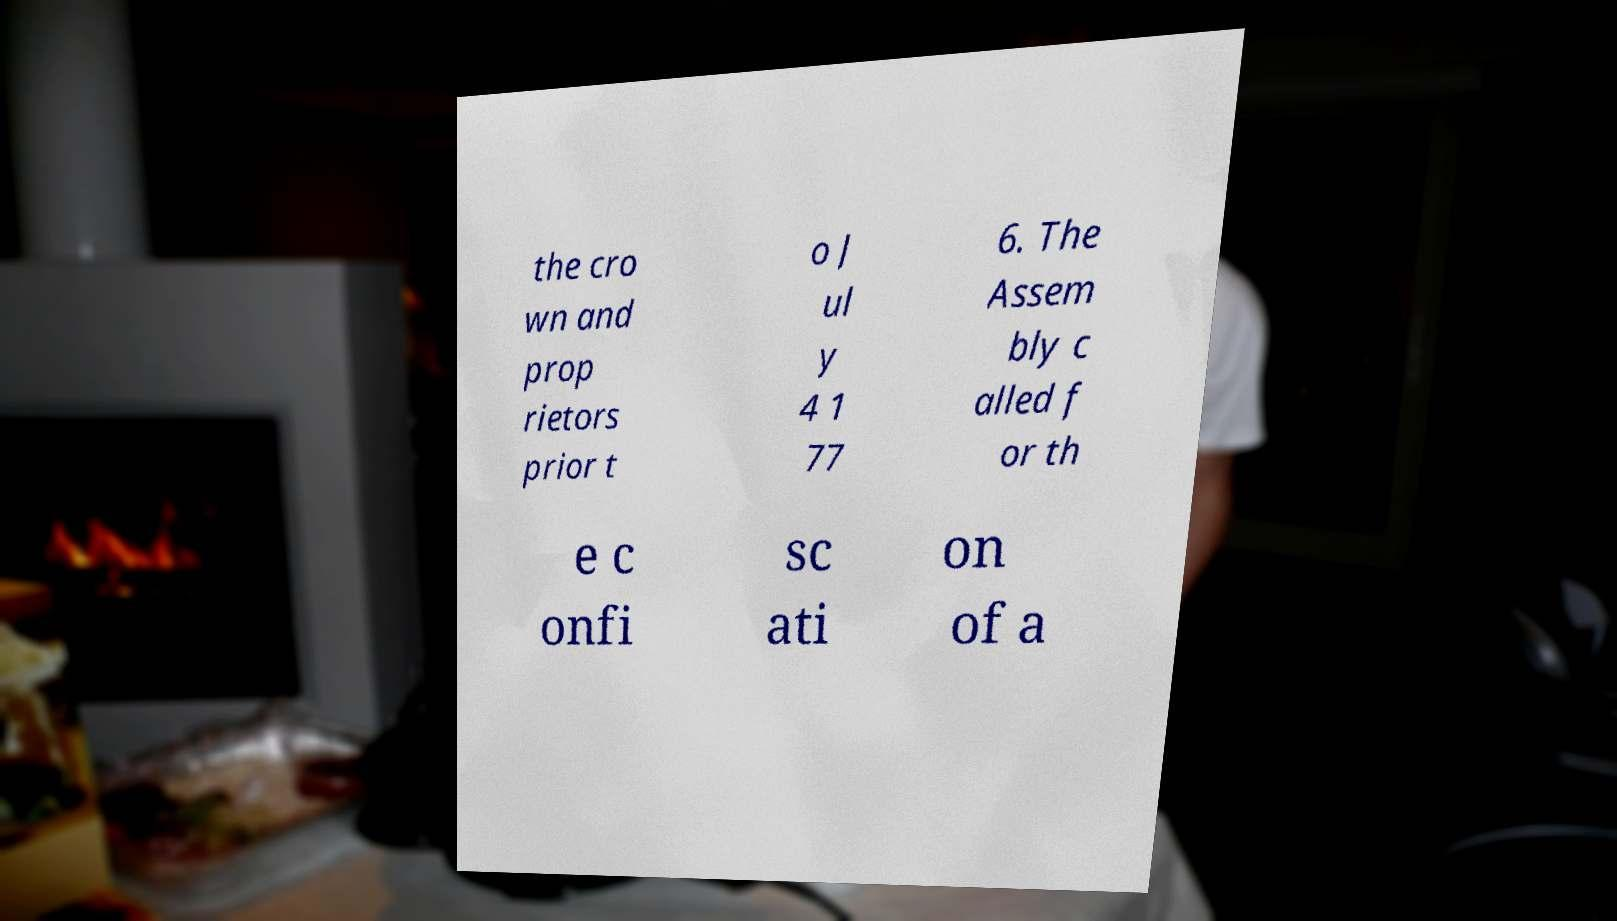I need the written content from this picture converted into text. Can you do that? the cro wn and prop rietors prior t o J ul y 4 1 77 6. The Assem bly c alled f or th e c onfi sc ati on of a 